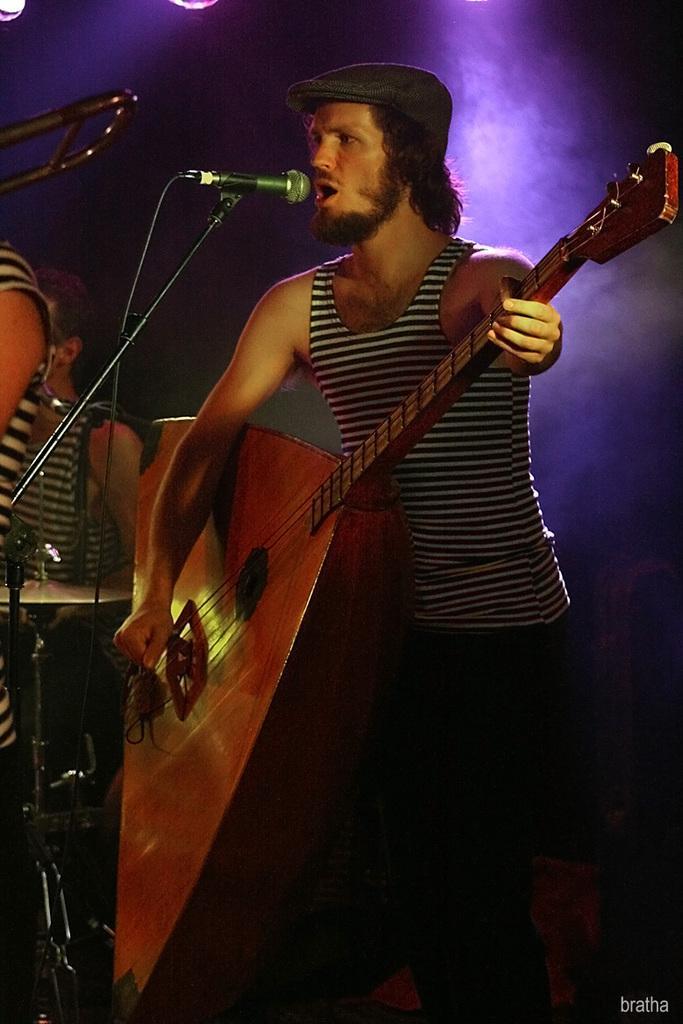How would you summarize this image in a sentence or two? This is the man standing. He is singing a song and playing musical instrument. This looks like a hi-hat instrument. There are two people standing. This is the mic attached to the mike stand. 